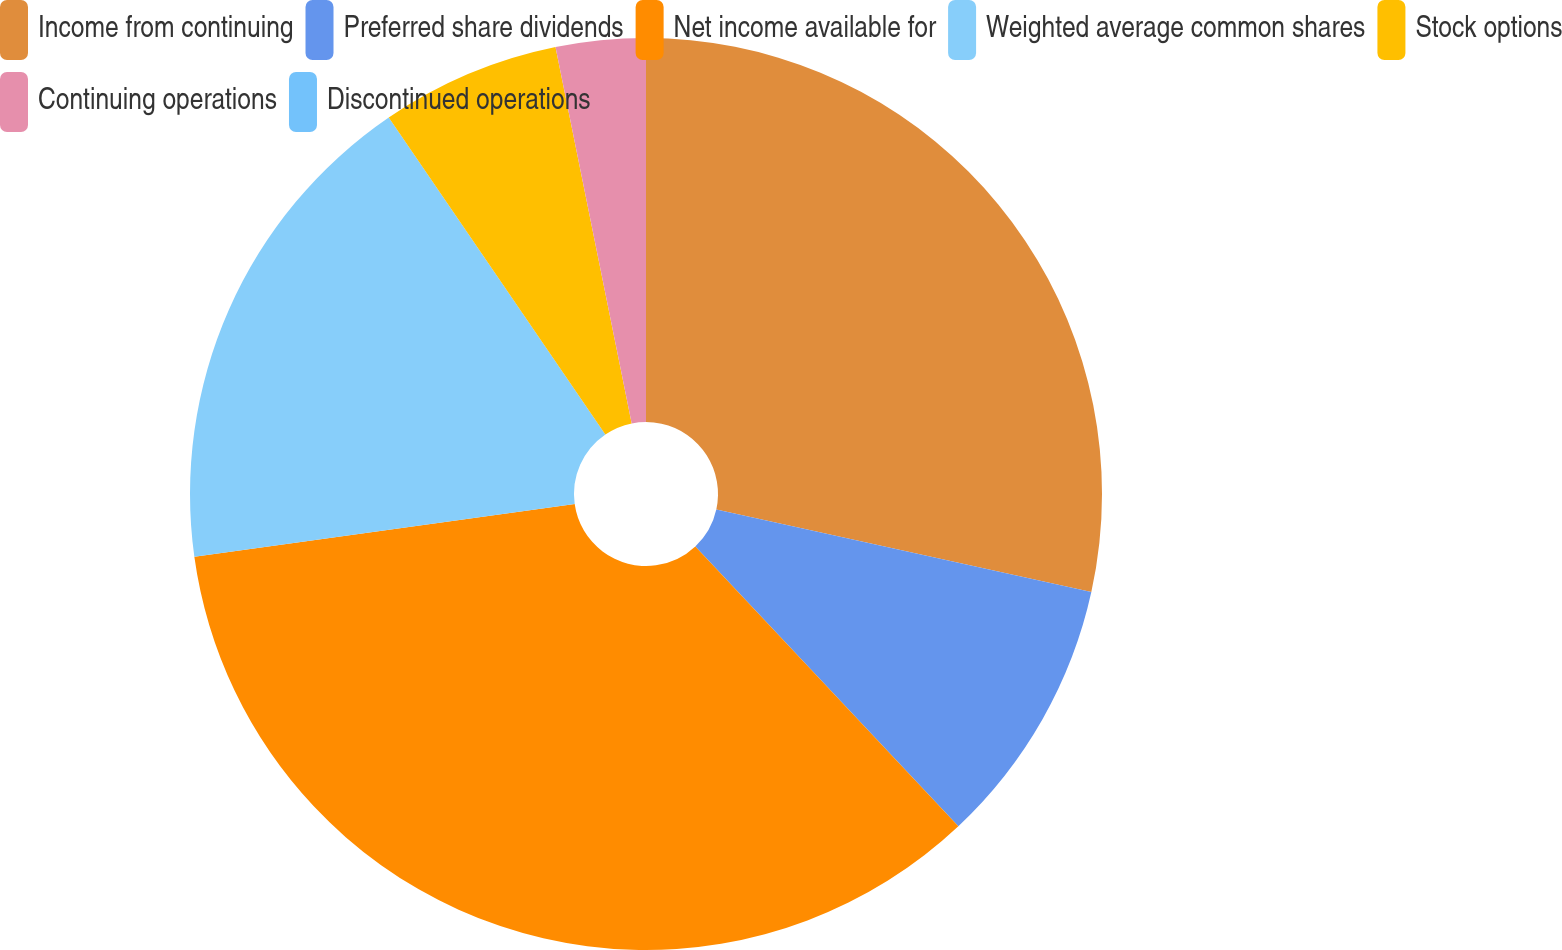Convert chart. <chart><loc_0><loc_0><loc_500><loc_500><pie_chart><fcel>Income from continuing<fcel>Preferred share dividends<fcel>Net income available for<fcel>Weighted average common shares<fcel>Stock options<fcel>Continuing operations<fcel>Discontinued operations<nl><fcel>28.45%<fcel>9.54%<fcel>34.81%<fcel>17.66%<fcel>6.36%<fcel>3.18%<fcel>0.0%<nl></chart> 